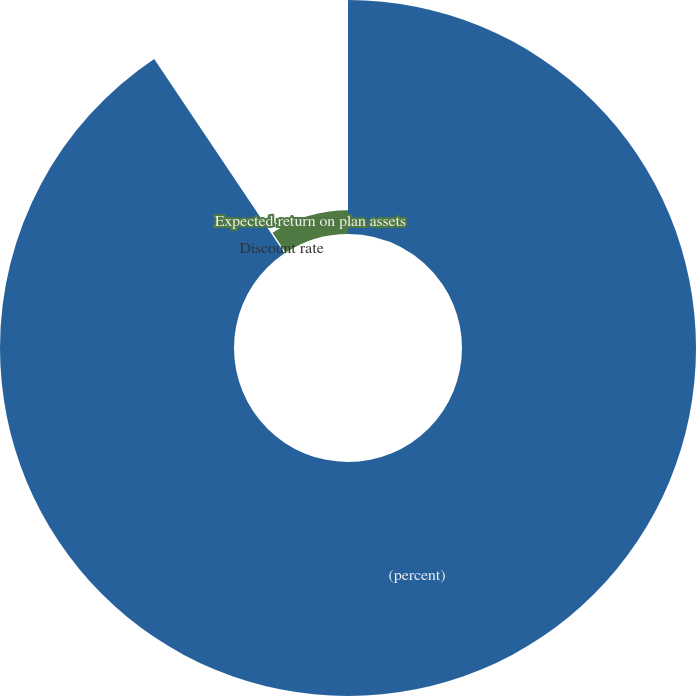<chart> <loc_0><loc_0><loc_500><loc_500><pie_chart><fcel>(percent)<fcel>Discount rate<fcel>Expected return on plan assets<nl><fcel>90.59%<fcel>0.18%<fcel>9.22%<nl></chart> 